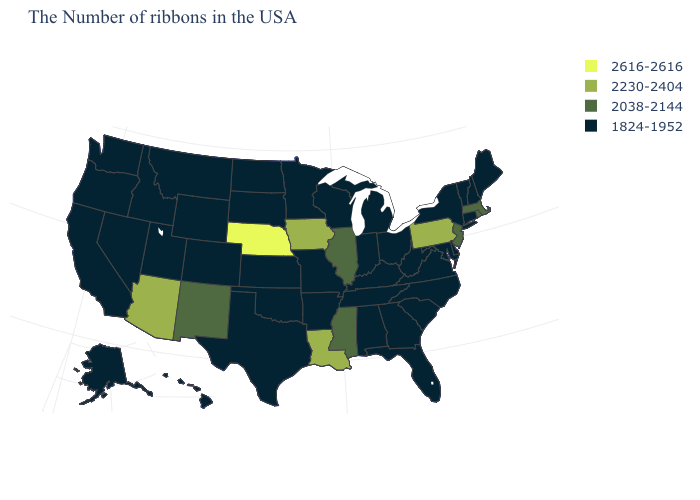What is the value of Nevada?
Be succinct. 1824-1952. Which states have the lowest value in the USA?
Keep it brief. Maine, New Hampshire, Vermont, Connecticut, New York, Delaware, Maryland, Virginia, North Carolina, South Carolina, West Virginia, Ohio, Florida, Georgia, Michigan, Kentucky, Indiana, Alabama, Tennessee, Wisconsin, Missouri, Arkansas, Minnesota, Kansas, Oklahoma, Texas, South Dakota, North Dakota, Wyoming, Colorado, Utah, Montana, Idaho, Nevada, California, Washington, Oregon, Alaska, Hawaii. Name the states that have a value in the range 1824-1952?
Keep it brief. Maine, New Hampshire, Vermont, Connecticut, New York, Delaware, Maryland, Virginia, North Carolina, South Carolina, West Virginia, Ohio, Florida, Georgia, Michigan, Kentucky, Indiana, Alabama, Tennessee, Wisconsin, Missouri, Arkansas, Minnesota, Kansas, Oklahoma, Texas, South Dakota, North Dakota, Wyoming, Colorado, Utah, Montana, Idaho, Nevada, California, Washington, Oregon, Alaska, Hawaii. Which states have the highest value in the USA?
Answer briefly. Nebraska. What is the lowest value in the USA?
Quick response, please. 1824-1952. Name the states that have a value in the range 2230-2404?
Keep it brief. Pennsylvania, Louisiana, Iowa, Arizona. Does Louisiana have the lowest value in the South?
Quick response, please. No. Does Kansas have the highest value in the MidWest?
Give a very brief answer. No. What is the value of Minnesota?
Give a very brief answer. 1824-1952. Does Oregon have the same value as Mississippi?
Be succinct. No. Is the legend a continuous bar?
Keep it brief. No. What is the value of Alabama?
Give a very brief answer. 1824-1952. Among the states that border Tennessee , does Mississippi have the highest value?
Short answer required. Yes. Does Delaware have the highest value in the USA?
Concise answer only. No. 